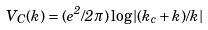Convert formula to latex. <formula><loc_0><loc_0><loc_500><loc_500>V _ { C } ( k ) = ( e ^ { 2 } / 2 \pi ) \log | ( k _ { c } + k ) / k |</formula> 